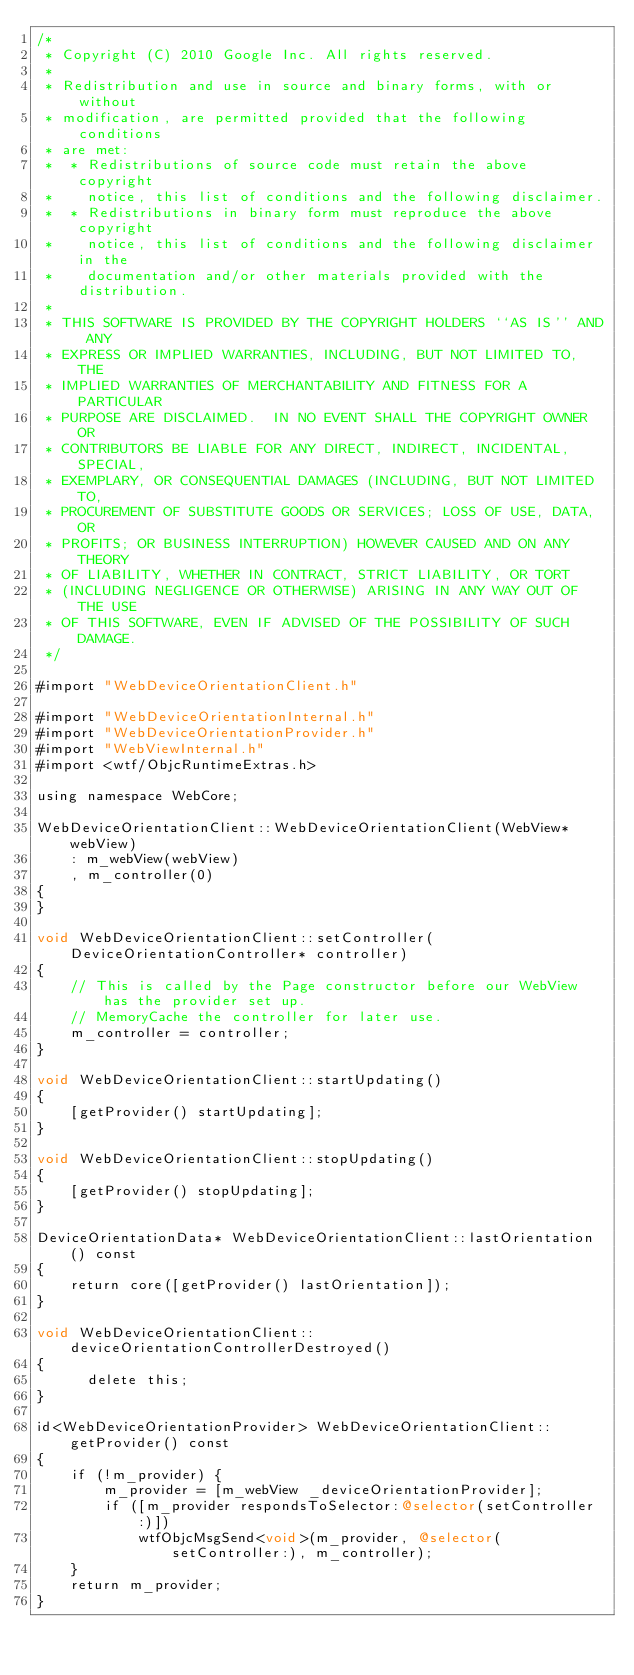<code> <loc_0><loc_0><loc_500><loc_500><_ObjectiveC_>/*
 * Copyright (C) 2010 Google Inc. All rights reserved.
 *
 * Redistribution and use in source and binary forms, with or without
 * modification, are permitted provided that the following conditions
 * are met:
 *  * Redistributions of source code must retain the above copyright
 *    notice, this list of conditions and the following disclaimer.
 *  * Redistributions in binary form must reproduce the above copyright
 *    notice, this list of conditions and the following disclaimer in the
 *    documentation and/or other materials provided with the distribution.
 *
 * THIS SOFTWARE IS PROVIDED BY THE COPYRIGHT HOLDERS ``AS IS'' AND ANY
 * EXPRESS OR IMPLIED WARRANTIES, INCLUDING, BUT NOT LIMITED TO, THE
 * IMPLIED WARRANTIES OF MERCHANTABILITY AND FITNESS FOR A PARTICULAR
 * PURPOSE ARE DISCLAIMED.  IN NO EVENT SHALL THE COPYRIGHT OWNER OR
 * CONTRIBUTORS BE LIABLE FOR ANY DIRECT, INDIRECT, INCIDENTAL, SPECIAL,
 * EXEMPLARY, OR CONSEQUENTIAL DAMAGES (INCLUDING, BUT NOT LIMITED TO,
 * PROCUREMENT OF SUBSTITUTE GOODS OR SERVICES; LOSS OF USE, DATA, OR
 * PROFITS; OR BUSINESS INTERRUPTION) HOWEVER CAUSED AND ON ANY THEORY
 * OF LIABILITY, WHETHER IN CONTRACT, STRICT LIABILITY, OR TORT
 * (INCLUDING NEGLIGENCE OR OTHERWISE) ARISING IN ANY WAY OUT OF THE USE
 * OF THIS SOFTWARE, EVEN IF ADVISED OF THE POSSIBILITY OF SUCH DAMAGE.
 */

#import "WebDeviceOrientationClient.h"

#import "WebDeviceOrientationInternal.h"
#import "WebDeviceOrientationProvider.h"
#import "WebViewInternal.h"
#import <wtf/ObjcRuntimeExtras.h>

using namespace WebCore;

WebDeviceOrientationClient::WebDeviceOrientationClient(WebView* webView)
    : m_webView(webView)
    , m_controller(0)
{
}

void WebDeviceOrientationClient::setController(DeviceOrientationController* controller)
{
    // This is called by the Page constructor before our WebView has the provider set up.
    // MemoryCache the controller for later use.
    m_controller = controller;
}

void WebDeviceOrientationClient::startUpdating()
{
    [getProvider() startUpdating];
}

void WebDeviceOrientationClient::stopUpdating()
{
    [getProvider() stopUpdating];
}

DeviceOrientationData* WebDeviceOrientationClient::lastOrientation() const
{
    return core([getProvider() lastOrientation]);
}

void WebDeviceOrientationClient::deviceOrientationControllerDestroyed()
{
      delete this;
}

id<WebDeviceOrientationProvider> WebDeviceOrientationClient::getProvider() const
{
    if (!m_provider) {
        m_provider = [m_webView _deviceOrientationProvider];
        if ([m_provider respondsToSelector:@selector(setController:)])
            wtfObjcMsgSend<void>(m_provider, @selector(setController:), m_controller);
    }
    return m_provider;
}
</code> 